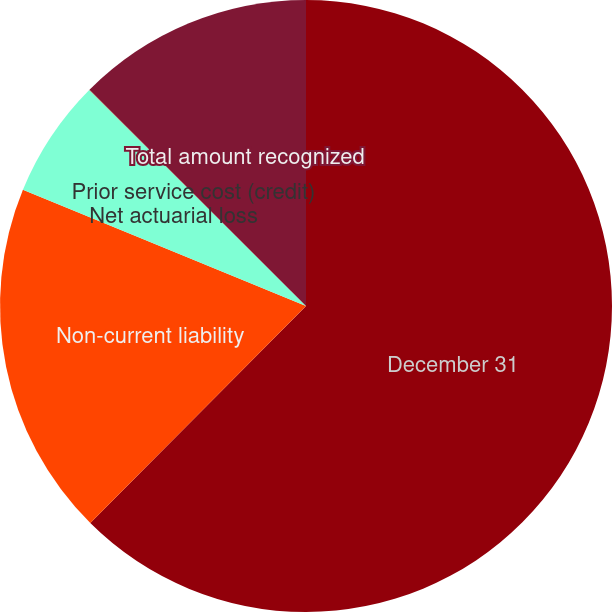Convert chart. <chart><loc_0><loc_0><loc_500><loc_500><pie_chart><fcel>December 31<fcel>Non-current liability<fcel>Net actuarial loss<fcel>Prior service cost (credit)<fcel>Total amount recognized<nl><fcel>62.45%<fcel>18.75%<fcel>6.27%<fcel>0.02%<fcel>12.51%<nl></chart> 